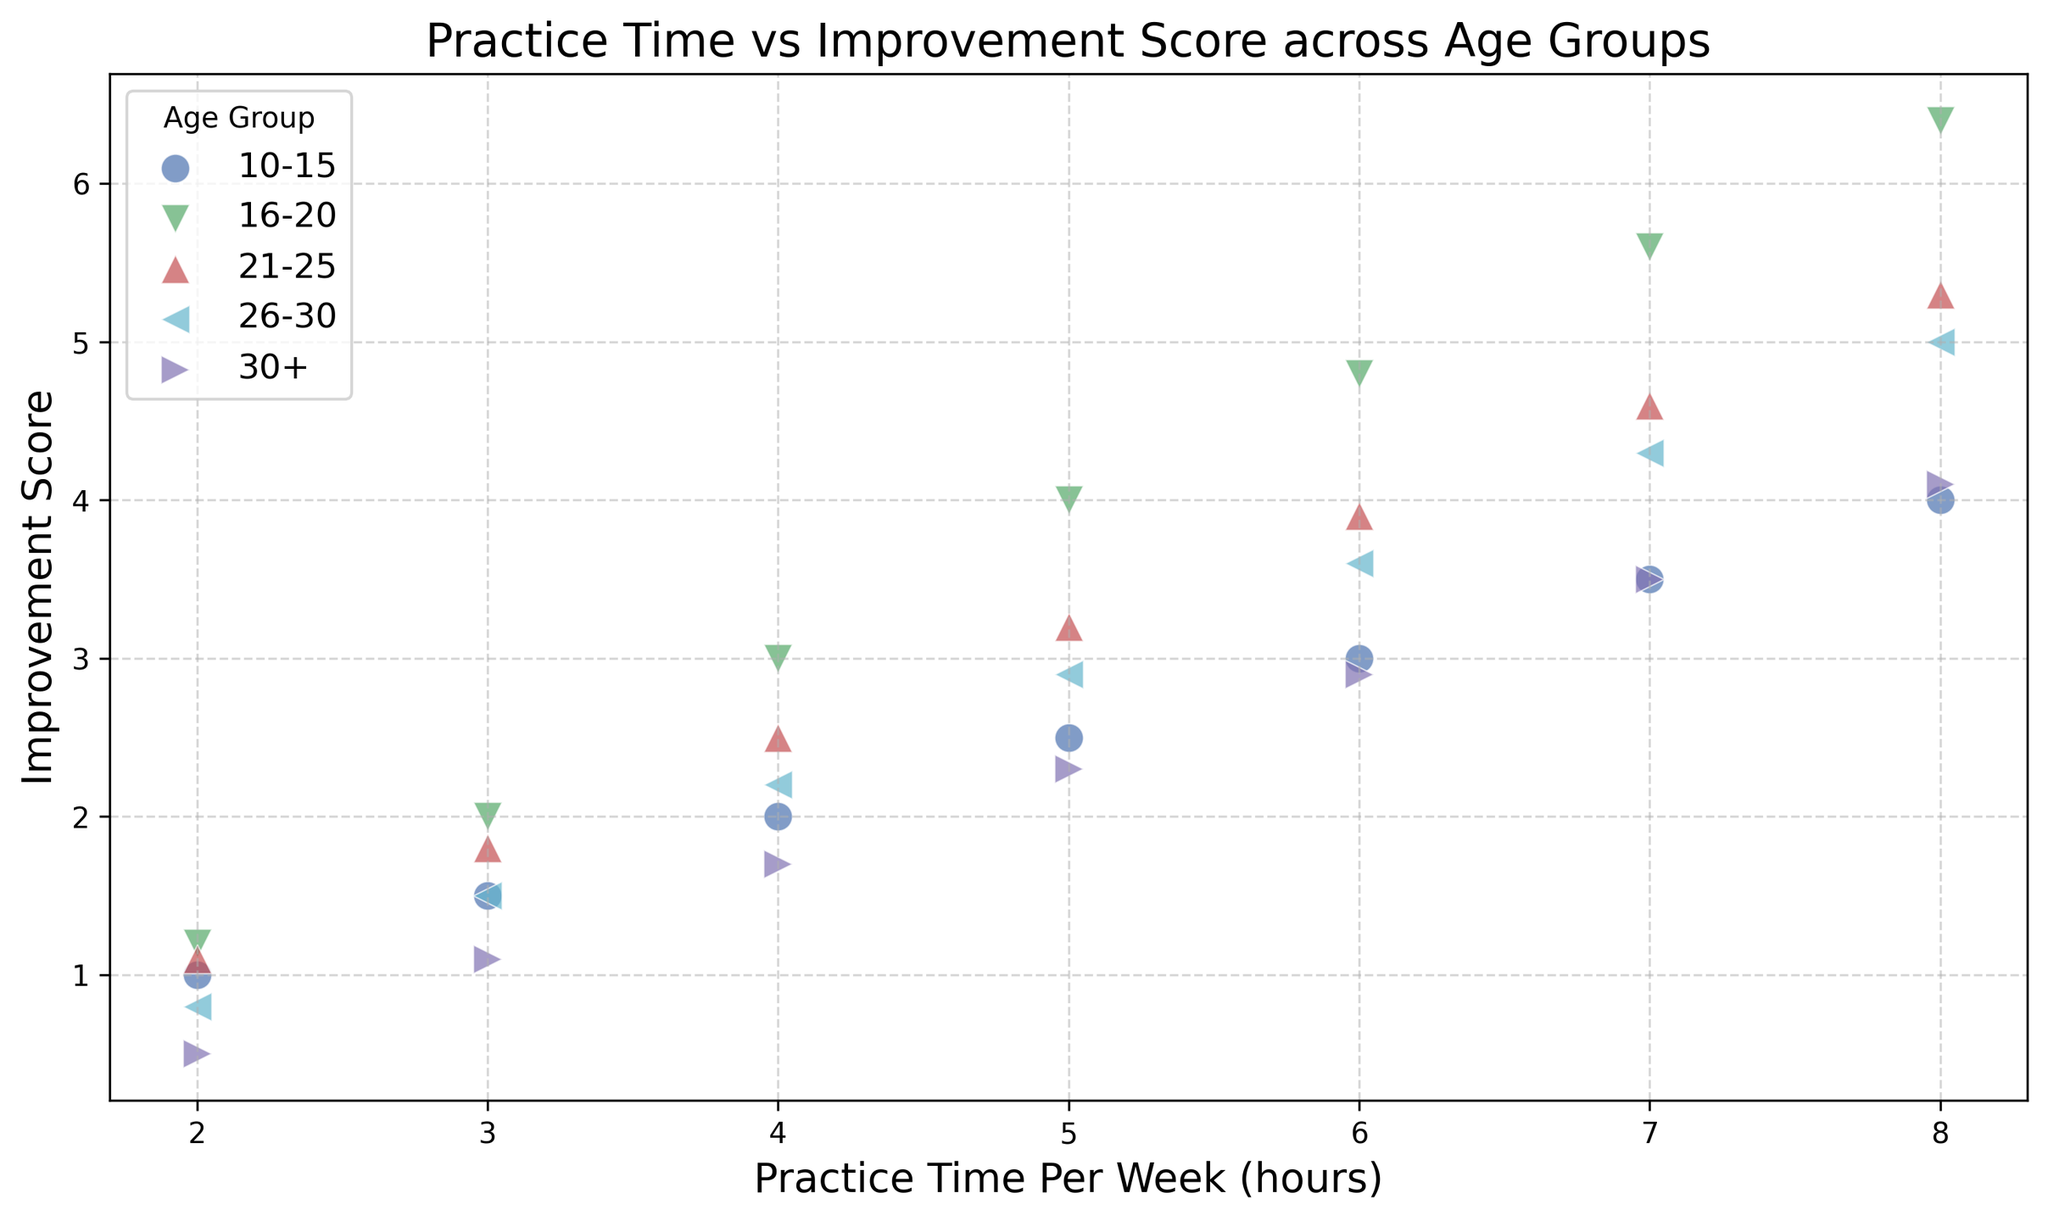Which age group shows the highest improvement score for 8 hours of practice per week? By examining the scatter plot, locate the highest improvement score points among different age groups with 8 hours of weekly practice. Compare the scores visually.
Answer: 16-20 Which age group has the lowest improvement score for 2 hours of practice time per week? Check the scatter plot for points associated with each age group for 2 hours of weekly practice. Identify the smallest improvement score among these points.
Answer: 30+ For the 21-25 age group, what is the difference in improvement scores between practicing 4 hours and 6 hours per week? Find the improvement scores for the 21-25 age group at 4 and 6 hours of practice time. Subtract the score at 4 hours from the score at 6 hours.
Answer: 1.4 Which age group has the steepest slope indicating rapid improvement as practice time increases? Visually examine the scatter points and their trends for each age group. The age group where points rise the steepest indicates rapid improvement.
Answer: 16-20 What is the most common color used to represent age groups on the scatter plot? Look at the scatter plot and identify the colors used for each age group. Count the occurrences to find the most frequent color.
Answer: Blue For the age group 26-30, how much does the improvement score increase from practicing 3 hours to 7 hours weekly? Identify the improvement scores for the 26-30 age group at 3 hours and 7 hours of practice. Subtract the score at 3 hours from the score at 7 hours to calculate the increase.
Answer: 2.8 Compare the improvement score of the 10-15 and 30+ age groups at 5 hours of practice per week. Which group shows better improvement? View the scatter points for the 10-15 and 30+ age groups at 5 hours of weekly practice. Compare the improvement scores visually to see which is higher.
Answer: 10-15 How does the improvement trend for the 16-20 age group compare visually to that of the 30+ age group? Examine the scatter points' spread and slopes for both age groups. Assess whether the 16-20 age group's trend rises more steeply than the 30+ age group's trend.
Answer: 16-20 is steeper 